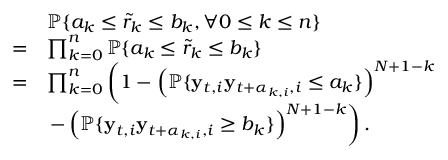Convert formula to latex. <formula><loc_0><loc_0><loc_500><loc_500>\begin{array} { r l } & { \mathbb { P } \{ a _ { k } \leq \tilde { r } _ { k } \leq b _ { k } , \forall 0 \leq k \leq n \} } \\ { = } & { \prod _ { k = 0 } ^ { n } \mathbb { P } \{ a _ { k } \leq \tilde { r } _ { k } \leq b _ { k } \} } \\ { = } & { \prod _ { k = 0 } ^ { n } \left ( 1 - \left ( \mathbb { P } \{ y _ { t , i } y _ { t + \alpha _ { k , i } , i } \leq a _ { k } \} \right ) ^ { N + 1 - k } } \\ & { - \left ( \mathbb { P } \{ y _ { t , i } y _ { t + \alpha _ { k , i } , i } \geq b _ { k } \} \right ) ^ { N + 1 - k } \right ) . } \end{array}</formula> 